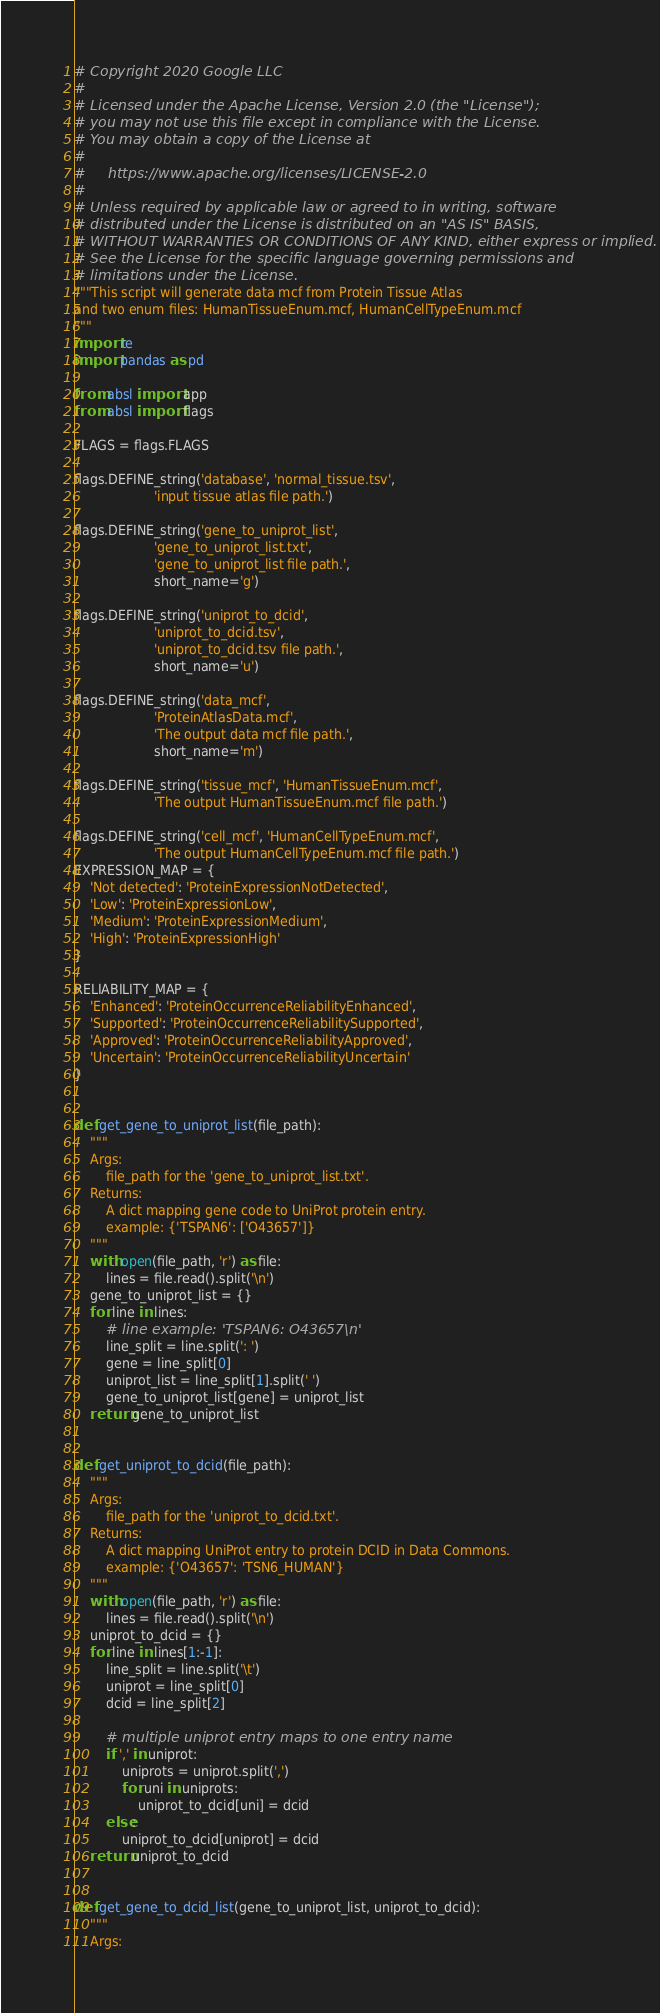Convert code to text. <code><loc_0><loc_0><loc_500><loc_500><_Python_># Copyright 2020 Google LLC
#
# Licensed under the Apache License, Version 2.0 (the "License");
# you may not use this file except in compliance with the License.
# You may obtain a copy of the License at
#
#     https://www.apache.org/licenses/LICENSE-2.0
#
# Unless required by applicable law or agreed to in writing, software
# distributed under the License is distributed on an "AS IS" BASIS,
# WITHOUT WARRANTIES OR CONDITIONS OF ANY KIND, either express or implied.
# See the License for the specific language governing permissions and
# limitations under the License.
"""This script will generate data mcf from Protein Tissue Atlas
and two enum files: HumanTissueEnum.mcf, HumanCellTypeEnum.mcf
"""
import re
import pandas as pd

from absl import app
from absl import flags

FLAGS = flags.FLAGS

flags.DEFINE_string('database', 'normal_tissue.tsv',
                    'input tissue atlas file path.')

flags.DEFINE_string('gene_to_uniprot_list',
                    'gene_to_uniprot_list.txt',
                    'gene_to_uniprot_list file path.',
                    short_name='g')

flags.DEFINE_string('uniprot_to_dcid',
                    'uniprot_to_dcid.tsv',
                    'uniprot_to_dcid.tsv file path.',
                    short_name='u')

flags.DEFINE_string('data_mcf',
                    'ProteinAtlasData.mcf',
                    'The output data mcf file path.',
                    short_name='m')

flags.DEFINE_string('tissue_mcf', 'HumanTissueEnum.mcf',
                    'The output HumanTissueEnum.mcf file path.')

flags.DEFINE_string('cell_mcf', 'HumanCellTypeEnum.mcf',
                    'The output HumanCellTypeEnum.mcf file path.')
EXPRESSION_MAP = {
    'Not detected': 'ProteinExpressionNotDetected',
    'Low': 'ProteinExpressionLow',
    'Medium': 'ProteinExpressionMedium',
    'High': 'ProteinExpressionHigh'
}

RELIABILITY_MAP = {
    'Enhanced': 'ProteinOccurrenceReliabilityEnhanced',
    'Supported': 'ProteinOccurrenceReliabilitySupported',
    'Approved': 'ProteinOccurrenceReliabilityApproved',
    'Uncertain': 'ProteinOccurrenceReliabilityUncertain'
}


def get_gene_to_uniprot_list(file_path):
    """
    Args:
        file_path for the 'gene_to_uniprot_list.txt'.
    Returns:
        A dict mapping gene code to UniProt protein entry.
        example: {'TSPAN6': ['O43657']}
    """
    with open(file_path, 'r') as file:
        lines = file.read().split('\n')
    gene_to_uniprot_list = {}
    for line in lines:
        # line example: 'TSPAN6: O43657\n'
        line_split = line.split(': ')
        gene = line_split[0]
        uniprot_list = line_split[1].split(' ')
        gene_to_uniprot_list[gene] = uniprot_list
    return gene_to_uniprot_list


def get_uniprot_to_dcid(file_path):
    """
    Args:
        file_path for the 'uniprot_to_dcid.txt'.
    Returns:
        A dict mapping UniProt entry to protein DCID in Data Commons.
        example: {'O43657': 'TSN6_HUMAN'}
    """
    with open(file_path, 'r') as file:
        lines = file.read().split('\n')
    uniprot_to_dcid = {}
    for line in lines[1:-1]:
        line_split = line.split('\t')
        uniprot = line_split[0]
        dcid = line_split[2]

        # multiple uniprot entry maps to one entry name
        if ',' in uniprot:
            uniprots = uniprot.split(',')
            for uni in uniprots:
                uniprot_to_dcid[uni] = dcid
        else:
            uniprot_to_dcid[uniprot] = dcid
    return uniprot_to_dcid


def get_gene_to_dcid_list(gene_to_uniprot_list, uniprot_to_dcid):
    """
    Args:</code> 